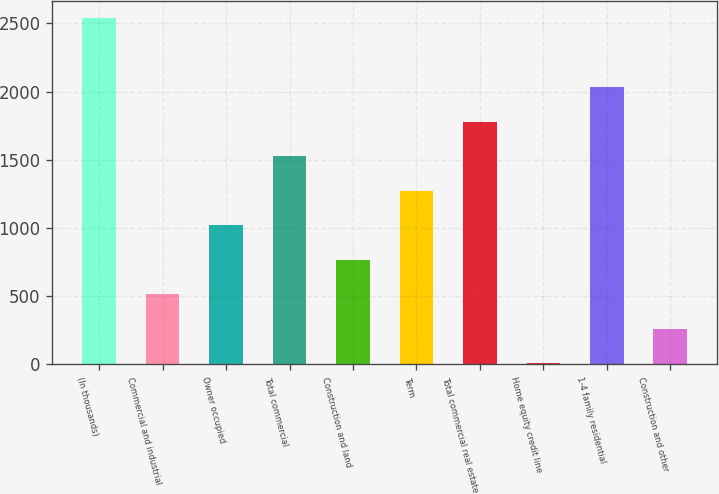Convert chart. <chart><loc_0><loc_0><loc_500><loc_500><bar_chart><fcel>(In thousands)<fcel>Commercial and industrial<fcel>Owner occupied<fcel>Total commercial<fcel>Construction and land<fcel>Term<fcel>Total commercial real estate<fcel>Home equity credit line<fcel>1-4 family residential<fcel>Construction and other<nl><fcel>2540<fcel>512<fcel>1019<fcel>1526<fcel>765.5<fcel>1272.5<fcel>1779.5<fcel>5<fcel>2033<fcel>258.5<nl></chart> 